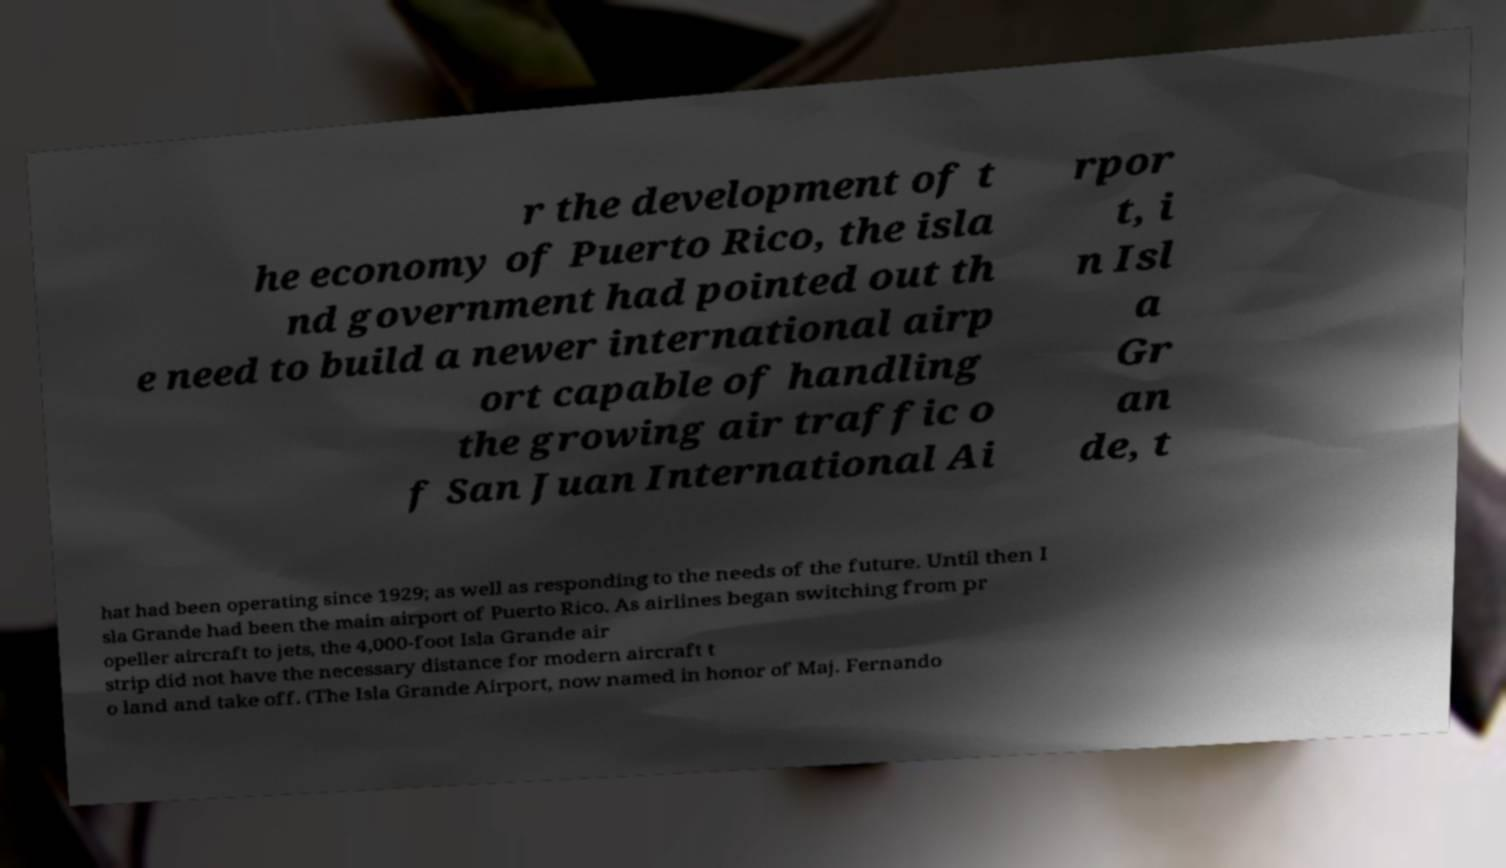Could you assist in decoding the text presented in this image and type it out clearly? r the development of t he economy of Puerto Rico, the isla nd government had pointed out th e need to build a newer international airp ort capable of handling the growing air traffic o f San Juan International Ai rpor t, i n Isl a Gr an de, t hat had been operating since 1929; as well as responding to the needs of the future. Until then I sla Grande had been the main airport of Puerto Rico. As airlines began switching from pr opeller aircraft to jets, the 4,000-foot Isla Grande air strip did not have the necessary distance for modern aircraft t o land and take off. (The Isla Grande Airport, now named in honor of Maj. Fernando 